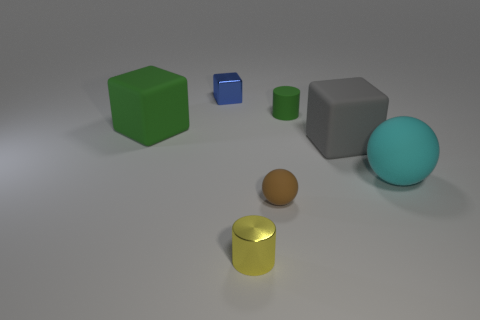Is the number of tiny shiny cylinders that are behind the brown matte sphere greater than the number of green rubber blocks?
Provide a succinct answer. No. The big gray thing behind the tiny yellow metallic object has what shape?
Your answer should be very brief. Cube. How many other things are the same shape as the small blue shiny object?
Offer a very short reply. 2. Is the material of the cylinder that is behind the cyan matte object the same as the cyan object?
Your answer should be very brief. Yes. Are there an equal number of green rubber things that are behind the tiny yellow cylinder and big cyan objects that are behind the gray cube?
Make the answer very short. No. There is a green rubber object that is in front of the tiny matte cylinder; how big is it?
Provide a succinct answer. Large. Are there any small purple balls that have the same material as the cyan object?
Ensure brevity in your answer.  No. There is a big matte cube to the right of the yellow cylinder; does it have the same color as the small shiny cylinder?
Give a very brief answer. No. Is the number of gray things behind the green cylinder the same as the number of tiny yellow shiny objects?
Your answer should be compact. No. Are there any blocks that have the same color as the small rubber cylinder?
Offer a terse response. Yes. 